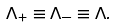Convert formula to latex. <formula><loc_0><loc_0><loc_500><loc_500>\Lambda _ { + } \equiv \Lambda _ { - } \equiv \Lambda .</formula> 